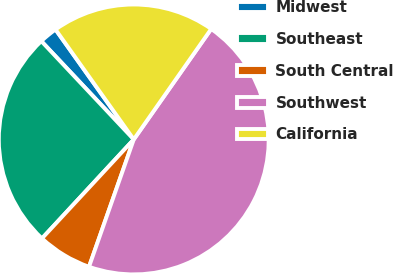Convert chart to OTSL. <chart><loc_0><loc_0><loc_500><loc_500><pie_chart><fcel>Midwest<fcel>Southeast<fcel>South Central<fcel>Southwest<fcel>California<nl><fcel>2.17%<fcel>26.09%<fcel>6.52%<fcel>45.65%<fcel>19.57%<nl></chart> 